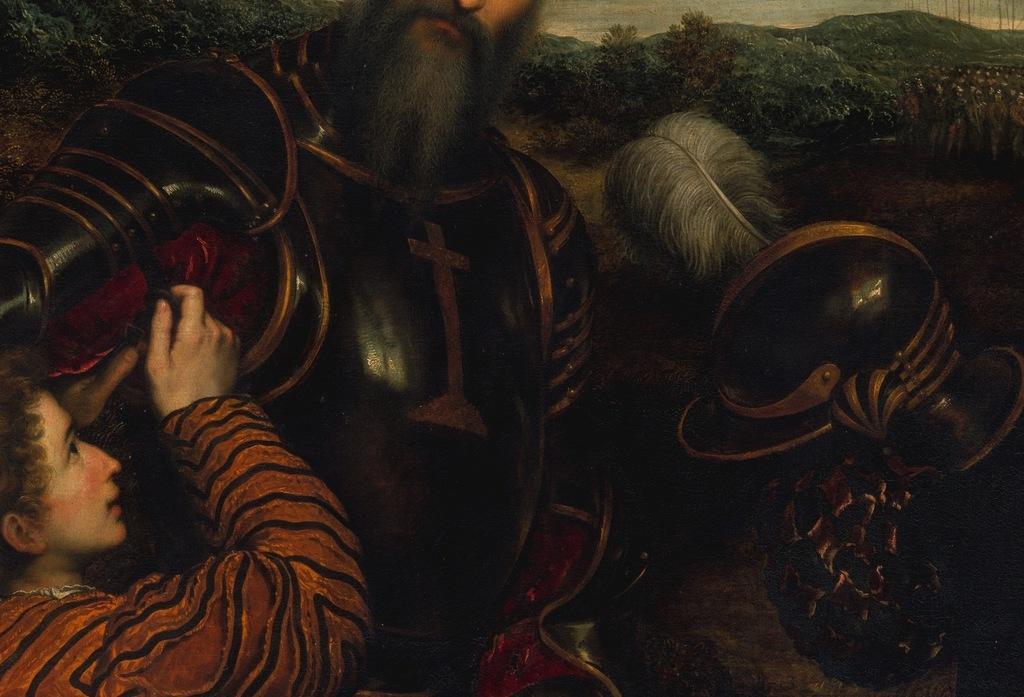Please provide a concise description of this image. In this image we can see a picture of two persons. On the right side of the image we can see a helmet with a feather on it. In the background, we can see a group of trees, hills and the sky. 